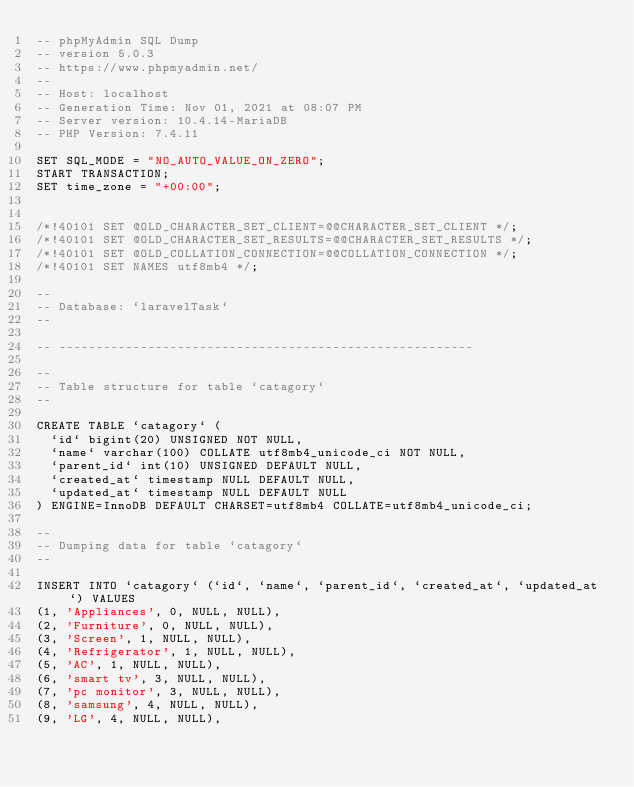<code> <loc_0><loc_0><loc_500><loc_500><_SQL_>-- phpMyAdmin SQL Dump
-- version 5.0.3
-- https://www.phpmyadmin.net/
--
-- Host: localhost
-- Generation Time: Nov 01, 2021 at 08:07 PM
-- Server version: 10.4.14-MariaDB
-- PHP Version: 7.4.11

SET SQL_MODE = "NO_AUTO_VALUE_ON_ZERO";
START TRANSACTION;
SET time_zone = "+00:00";


/*!40101 SET @OLD_CHARACTER_SET_CLIENT=@@CHARACTER_SET_CLIENT */;
/*!40101 SET @OLD_CHARACTER_SET_RESULTS=@@CHARACTER_SET_RESULTS */;
/*!40101 SET @OLD_COLLATION_CONNECTION=@@COLLATION_CONNECTION */;
/*!40101 SET NAMES utf8mb4 */;

--
-- Database: `laravelTask`
--

-- --------------------------------------------------------

--
-- Table structure for table `catagory`
--

CREATE TABLE `catagory` (
  `id` bigint(20) UNSIGNED NOT NULL,
  `name` varchar(100) COLLATE utf8mb4_unicode_ci NOT NULL,
  `parent_id` int(10) UNSIGNED DEFAULT NULL,
  `created_at` timestamp NULL DEFAULT NULL,
  `updated_at` timestamp NULL DEFAULT NULL
) ENGINE=InnoDB DEFAULT CHARSET=utf8mb4 COLLATE=utf8mb4_unicode_ci;

--
-- Dumping data for table `catagory`
--

INSERT INTO `catagory` (`id`, `name`, `parent_id`, `created_at`, `updated_at`) VALUES
(1, 'Appliances', 0, NULL, NULL),
(2, 'Furniture', 0, NULL, NULL),
(3, 'Screen', 1, NULL, NULL),
(4, 'Refrigerator', 1, NULL, NULL),
(5, 'AC', 1, NULL, NULL),
(6, 'smart tv', 3, NULL, NULL),
(7, 'pc monitor', 3, NULL, NULL),
(8, 'samsung', 4, NULL, NULL),
(9, 'LG', 4, NULL, NULL),</code> 